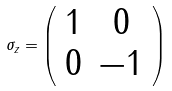Convert formula to latex. <formula><loc_0><loc_0><loc_500><loc_500>\sigma _ { z } = \left ( \begin{array} { c c } 1 & 0 \\ 0 & - 1 \end{array} \right )</formula> 